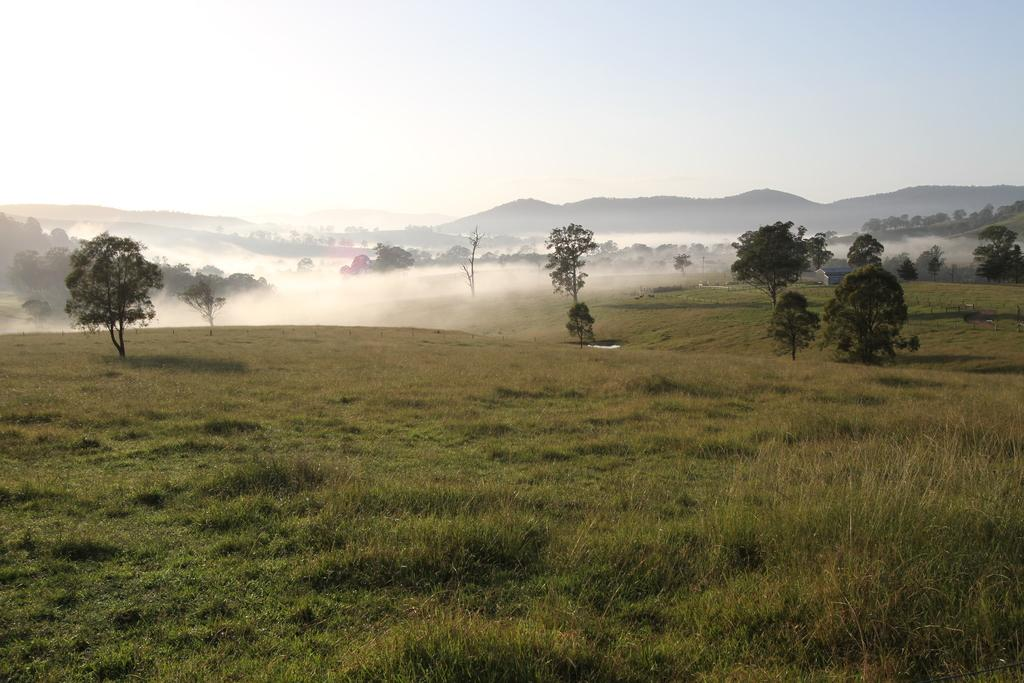What type of vegetation can be seen in the image? There are trees in the image. What can be seen in the distance in the image? There are hills in the background of the image. What type of structure is visible in the background of the image? There is at least one building in the background of the image. What type of ground cover is visible in the foreground of the image? There is grass visible in the foreground of the image. How many strings are attached to the trees in the image? There are no strings attached to the trees in the image. What type of vehicles can be seen driving on the grass in the image? There are no vehicles visible in the image; it only features trees, hills, a building, and grass. 